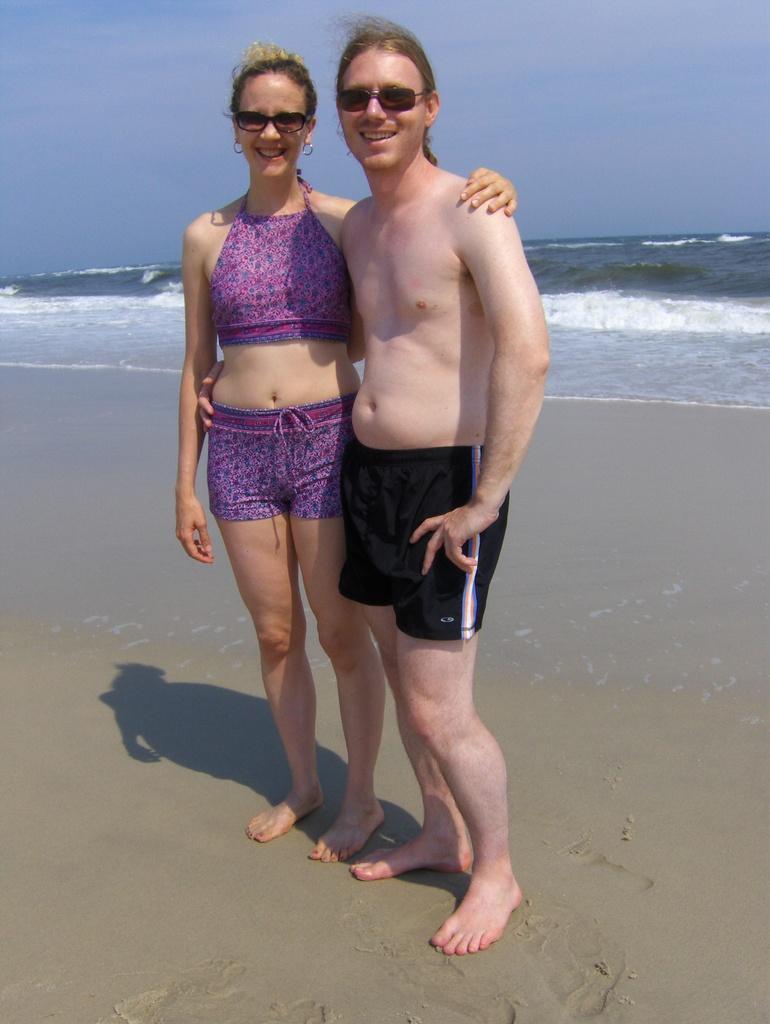Could you give a brief overview of what you see in this image? In this image we can see two people standing on a sea shore. In the background of the image there is ocean, sky. At the bottom of the image there is sand. 